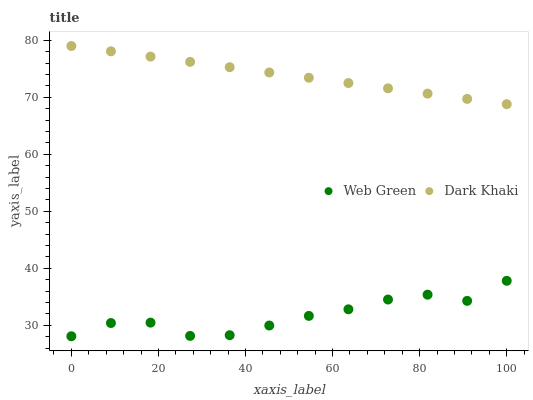Does Web Green have the minimum area under the curve?
Answer yes or no. Yes. Does Dark Khaki have the maximum area under the curve?
Answer yes or no. Yes. Does Web Green have the maximum area under the curve?
Answer yes or no. No. Is Dark Khaki the smoothest?
Answer yes or no. Yes. Is Web Green the roughest?
Answer yes or no. Yes. Is Web Green the smoothest?
Answer yes or no. No. Does Web Green have the lowest value?
Answer yes or no. Yes. Does Dark Khaki have the highest value?
Answer yes or no. Yes. Does Web Green have the highest value?
Answer yes or no. No. Is Web Green less than Dark Khaki?
Answer yes or no. Yes. Is Dark Khaki greater than Web Green?
Answer yes or no. Yes. Does Web Green intersect Dark Khaki?
Answer yes or no. No. 